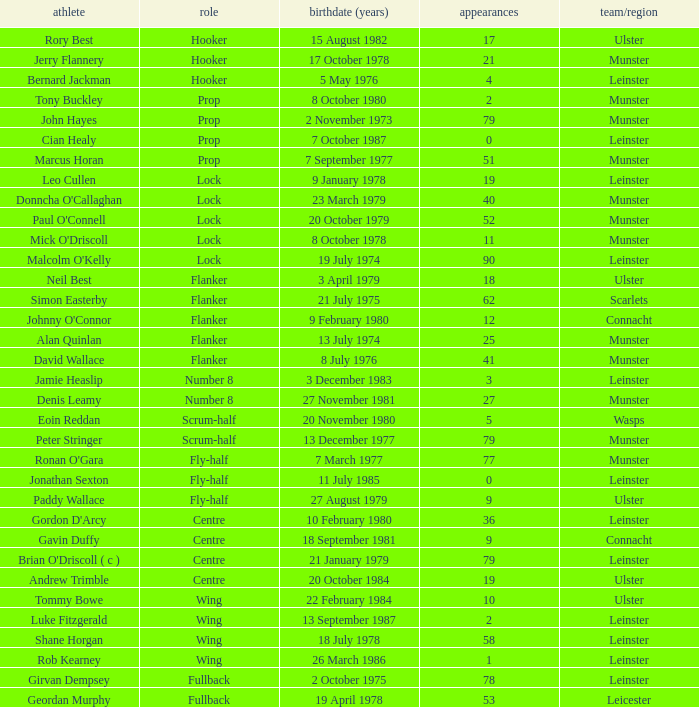What Club/province have caps less than 2 and Jonathan Sexton as player? Leinster. 